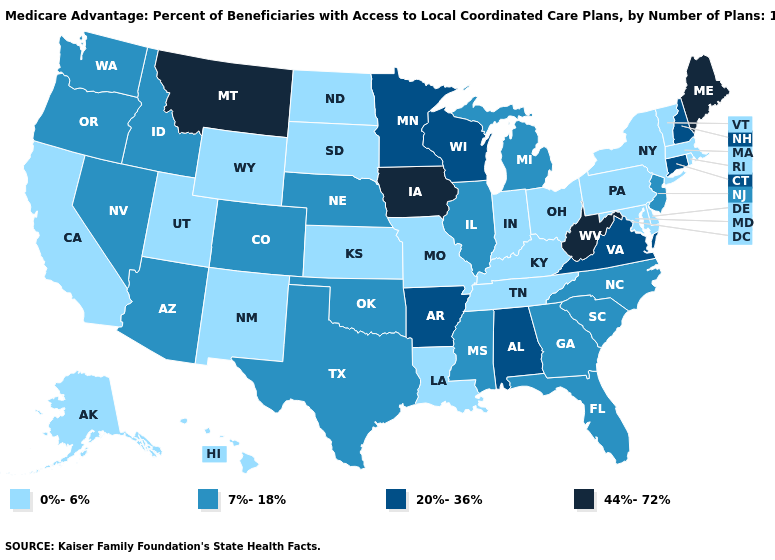What is the value of Wyoming?
Quick response, please. 0%-6%. What is the lowest value in the Northeast?
Quick response, please. 0%-6%. Does Rhode Island have the highest value in the USA?
Concise answer only. No. Does Texas have a lower value than Kansas?
Give a very brief answer. No. How many symbols are there in the legend?
Give a very brief answer. 4. Name the states that have a value in the range 20%-36%?
Give a very brief answer. Alabama, Arkansas, Connecticut, Minnesota, New Hampshire, Virginia, Wisconsin. Does North Carolina have the lowest value in the South?
Write a very short answer. No. Does Missouri have a lower value than Utah?
Short answer required. No. What is the highest value in the South ?
Short answer required. 44%-72%. Does the first symbol in the legend represent the smallest category?
Give a very brief answer. Yes. Is the legend a continuous bar?
Short answer required. No. What is the value of North Dakota?
Keep it brief. 0%-6%. Among the states that border Delaware , does Maryland have the lowest value?
Give a very brief answer. Yes. Does Minnesota have the same value as Arkansas?
Answer briefly. Yes. What is the highest value in the USA?
Concise answer only. 44%-72%. 